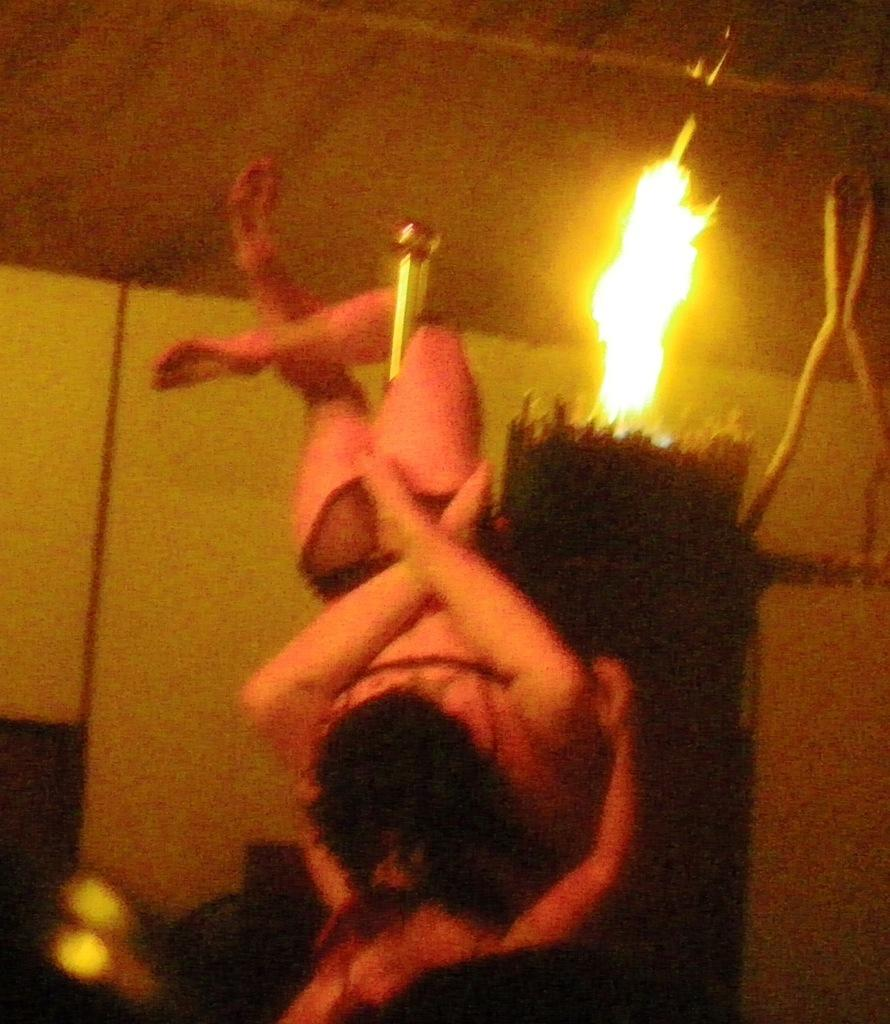How many people are in the image? There are two persons in the image. What is between the two persons? There is a pole between the two persons. What can be seen in the background of the image? There is a fire in the background of the image. What language are the two persons speaking in the image? The image does not provide any information about the language being spoken by the two persons. Can you see any cracks in the ground in the image? There is no mention of a ground or any cracks in the image; it only features two persons and a pole, as well as a fire in the background. 